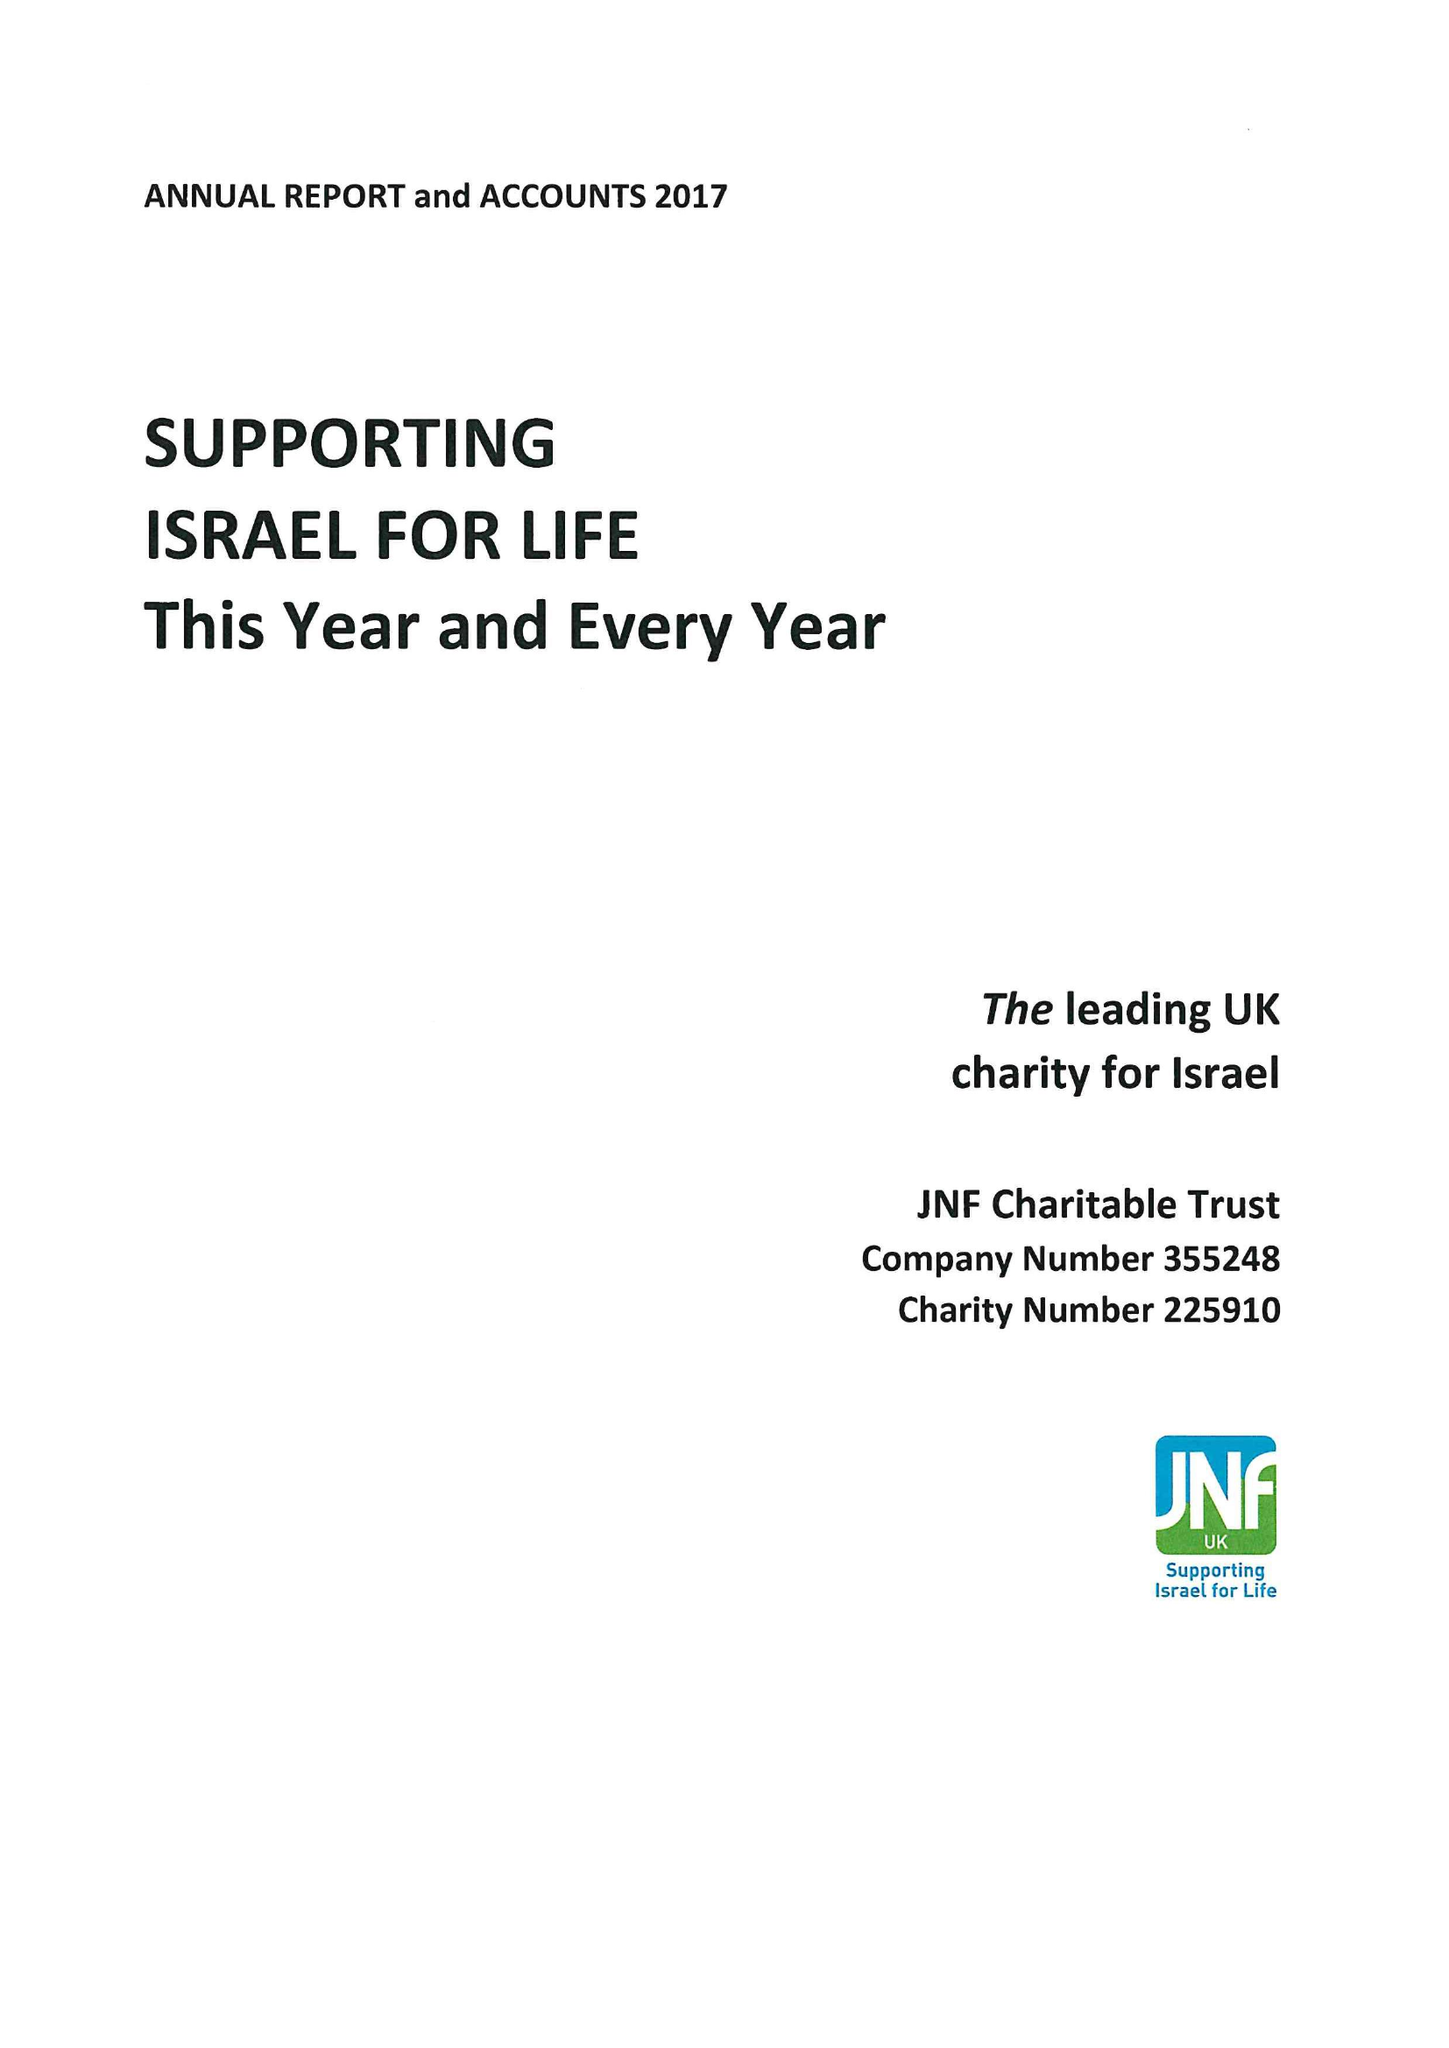What is the value for the spending_annually_in_british_pounds?
Answer the question using a single word or phrase. 10165000.00 